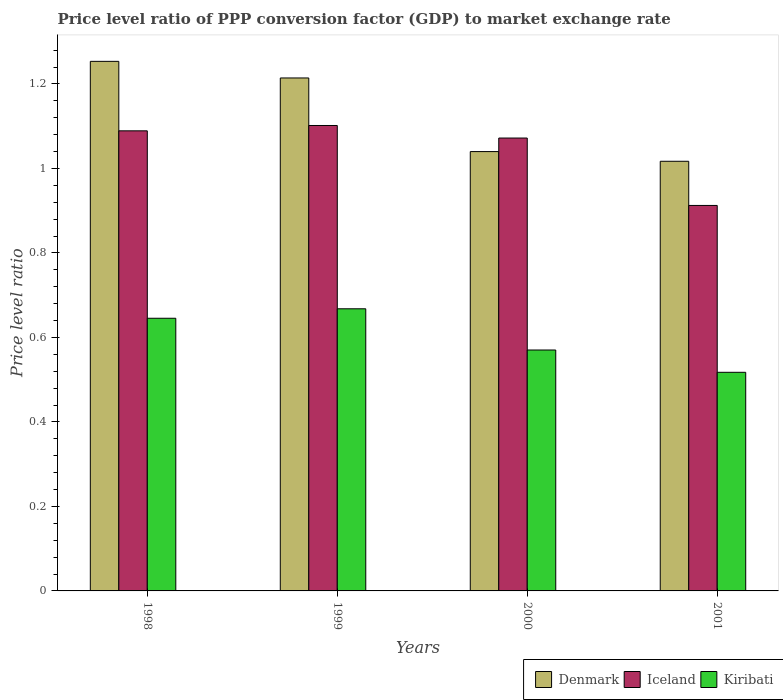How many different coloured bars are there?
Your answer should be very brief. 3. How many bars are there on the 3rd tick from the right?
Offer a very short reply. 3. What is the price level ratio in Denmark in 1999?
Offer a terse response. 1.21. Across all years, what is the maximum price level ratio in Kiribati?
Offer a terse response. 0.67. Across all years, what is the minimum price level ratio in Kiribati?
Give a very brief answer. 0.52. In which year was the price level ratio in Iceland maximum?
Make the answer very short. 1999. What is the total price level ratio in Denmark in the graph?
Ensure brevity in your answer.  4.52. What is the difference between the price level ratio in Iceland in 1999 and that in 2000?
Your response must be concise. 0.03. What is the difference between the price level ratio in Kiribati in 1998 and the price level ratio in Denmark in 2001?
Your response must be concise. -0.37. What is the average price level ratio in Denmark per year?
Keep it short and to the point. 1.13. In the year 1998, what is the difference between the price level ratio in Iceland and price level ratio in Denmark?
Your response must be concise. -0.16. What is the ratio of the price level ratio in Kiribati in 1998 to that in 2001?
Keep it short and to the point. 1.25. Is the price level ratio in Iceland in 1998 less than that in 1999?
Offer a very short reply. Yes. What is the difference between the highest and the second highest price level ratio in Iceland?
Offer a terse response. 0.01. What is the difference between the highest and the lowest price level ratio in Iceland?
Your answer should be compact. 0.19. In how many years, is the price level ratio in Iceland greater than the average price level ratio in Iceland taken over all years?
Provide a succinct answer. 3. What does the 1st bar from the right in 1998 represents?
Offer a terse response. Kiribati. Is it the case that in every year, the sum of the price level ratio in Iceland and price level ratio in Kiribati is greater than the price level ratio in Denmark?
Your answer should be very brief. Yes. Are all the bars in the graph horizontal?
Offer a terse response. No. How many years are there in the graph?
Offer a terse response. 4. Does the graph contain grids?
Offer a terse response. No. Where does the legend appear in the graph?
Provide a short and direct response. Bottom right. How many legend labels are there?
Offer a terse response. 3. How are the legend labels stacked?
Ensure brevity in your answer.  Horizontal. What is the title of the graph?
Make the answer very short. Price level ratio of PPP conversion factor (GDP) to market exchange rate. What is the label or title of the X-axis?
Offer a very short reply. Years. What is the label or title of the Y-axis?
Provide a short and direct response. Price level ratio. What is the Price level ratio in Denmark in 1998?
Your answer should be compact. 1.25. What is the Price level ratio of Iceland in 1998?
Keep it short and to the point. 1.09. What is the Price level ratio of Kiribati in 1998?
Provide a short and direct response. 0.65. What is the Price level ratio in Denmark in 1999?
Your answer should be compact. 1.21. What is the Price level ratio of Iceland in 1999?
Keep it short and to the point. 1.1. What is the Price level ratio in Kiribati in 1999?
Make the answer very short. 0.67. What is the Price level ratio in Denmark in 2000?
Offer a very short reply. 1.04. What is the Price level ratio in Iceland in 2000?
Make the answer very short. 1.07. What is the Price level ratio of Kiribati in 2000?
Your answer should be very brief. 0.57. What is the Price level ratio of Denmark in 2001?
Your answer should be compact. 1.02. What is the Price level ratio of Iceland in 2001?
Keep it short and to the point. 0.91. What is the Price level ratio in Kiribati in 2001?
Your answer should be very brief. 0.52. Across all years, what is the maximum Price level ratio of Denmark?
Give a very brief answer. 1.25. Across all years, what is the maximum Price level ratio of Iceland?
Your answer should be compact. 1.1. Across all years, what is the maximum Price level ratio in Kiribati?
Keep it short and to the point. 0.67. Across all years, what is the minimum Price level ratio in Denmark?
Give a very brief answer. 1.02. Across all years, what is the minimum Price level ratio in Iceland?
Give a very brief answer. 0.91. Across all years, what is the minimum Price level ratio in Kiribati?
Offer a very short reply. 0.52. What is the total Price level ratio in Denmark in the graph?
Your answer should be compact. 4.52. What is the total Price level ratio in Iceland in the graph?
Keep it short and to the point. 4.17. What is the total Price level ratio of Kiribati in the graph?
Offer a very short reply. 2.4. What is the difference between the Price level ratio of Denmark in 1998 and that in 1999?
Keep it short and to the point. 0.04. What is the difference between the Price level ratio in Iceland in 1998 and that in 1999?
Your response must be concise. -0.01. What is the difference between the Price level ratio of Kiribati in 1998 and that in 1999?
Your response must be concise. -0.02. What is the difference between the Price level ratio in Denmark in 1998 and that in 2000?
Give a very brief answer. 0.21. What is the difference between the Price level ratio of Iceland in 1998 and that in 2000?
Provide a short and direct response. 0.02. What is the difference between the Price level ratio of Kiribati in 1998 and that in 2000?
Your response must be concise. 0.08. What is the difference between the Price level ratio in Denmark in 1998 and that in 2001?
Make the answer very short. 0.24. What is the difference between the Price level ratio of Iceland in 1998 and that in 2001?
Ensure brevity in your answer.  0.18. What is the difference between the Price level ratio of Kiribati in 1998 and that in 2001?
Ensure brevity in your answer.  0.13. What is the difference between the Price level ratio of Denmark in 1999 and that in 2000?
Make the answer very short. 0.17. What is the difference between the Price level ratio of Iceland in 1999 and that in 2000?
Keep it short and to the point. 0.03. What is the difference between the Price level ratio of Kiribati in 1999 and that in 2000?
Provide a short and direct response. 0.1. What is the difference between the Price level ratio of Denmark in 1999 and that in 2001?
Provide a short and direct response. 0.2. What is the difference between the Price level ratio in Iceland in 1999 and that in 2001?
Provide a succinct answer. 0.19. What is the difference between the Price level ratio in Kiribati in 1999 and that in 2001?
Your answer should be very brief. 0.15. What is the difference between the Price level ratio in Denmark in 2000 and that in 2001?
Offer a very short reply. 0.02. What is the difference between the Price level ratio of Iceland in 2000 and that in 2001?
Ensure brevity in your answer.  0.16. What is the difference between the Price level ratio in Kiribati in 2000 and that in 2001?
Offer a terse response. 0.05. What is the difference between the Price level ratio in Denmark in 1998 and the Price level ratio in Iceland in 1999?
Your response must be concise. 0.15. What is the difference between the Price level ratio of Denmark in 1998 and the Price level ratio of Kiribati in 1999?
Make the answer very short. 0.59. What is the difference between the Price level ratio in Iceland in 1998 and the Price level ratio in Kiribati in 1999?
Provide a succinct answer. 0.42. What is the difference between the Price level ratio of Denmark in 1998 and the Price level ratio of Iceland in 2000?
Offer a terse response. 0.18. What is the difference between the Price level ratio in Denmark in 1998 and the Price level ratio in Kiribati in 2000?
Provide a succinct answer. 0.68. What is the difference between the Price level ratio of Iceland in 1998 and the Price level ratio of Kiribati in 2000?
Keep it short and to the point. 0.52. What is the difference between the Price level ratio in Denmark in 1998 and the Price level ratio in Iceland in 2001?
Provide a short and direct response. 0.34. What is the difference between the Price level ratio of Denmark in 1998 and the Price level ratio of Kiribati in 2001?
Your answer should be compact. 0.74. What is the difference between the Price level ratio of Iceland in 1998 and the Price level ratio of Kiribati in 2001?
Give a very brief answer. 0.57. What is the difference between the Price level ratio in Denmark in 1999 and the Price level ratio in Iceland in 2000?
Ensure brevity in your answer.  0.14. What is the difference between the Price level ratio in Denmark in 1999 and the Price level ratio in Kiribati in 2000?
Your answer should be compact. 0.64. What is the difference between the Price level ratio in Iceland in 1999 and the Price level ratio in Kiribati in 2000?
Provide a short and direct response. 0.53. What is the difference between the Price level ratio of Denmark in 1999 and the Price level ratio of Iceland in 2001?
Make the answer very short. 0.3. What is the difference between the Price level ratio in Denmark in 1999 and the Price level ratio in Kiribati in 2001?
Your answer should be compact. 0.7. What is the difference between the Price level ratio of Iceland in 1999 and the Price level ratio of Kiribati in 2001?
Ensure brevity in your answer.  0.58. What is the difference between the Price level ratio in Denmark in 2000 and the Price level ratio in Iceland in 2001?
Provide a succinct answer. 0.13. What is the difference between the Price level ratio in Denmark in 2000 and the Price level ratio in Kiribati in 2001?
Your response must be concise. 0.52. What is the difference between the Price level ratio of Iceland in 2000 and the Price level ratio of Kiribati in 2001?
Keep it short and to the point. 0.55. What is the average Price level ratio in Denmark per year?
Offer a very short reply. 1.13. What is the average Price level ratio in Iceland per year?
Provide a short and direct response. 1.04. What is the average Price level ratio of Kiribati per year?
Your answer should be very brief. 0.6. In the year 1998, what is the difference between the Price level ratio of Denmark and Price level ratio of Iceland?
Provide a succinct answer. 0.16. In the year 1998, what is the difference between the Price level ratio of Denmark and Price level ratio of Kiribati?
Provide a succinct answer. 0.61. In the year 1998, what is the difference between the Price level ratio in Iceland and Price level ratio in Kiribati?
Offer a terse response. 0.44. In the year 1999, what is the difference between the Price level ratio of Denmark and Price level ratio of Iceland?
Make the answer very short. 0.11. In the year 1999, what is the difference between the Price level ratio in Denmark and Price level ratio in Kiribati?
Ensure brevity in your answer.  0.55. In the year 1999, what is the difference between the Price level ratio of Iceland and Price level ratio of Kiribati?
Keep it short and to the point. 0.43. In the year 2000, what is the difference between the Price level ratio of Denmark and Price level ratio of Iceland?
Provide a succinct answer. -0.03. In the year 2000, what is the difference between the Price level ratio in Denmark and Price level ratio in Kiribati?
Give a very brief answer. 0.47. In the year 2000, what is the difference between the Price level ratio of Iceland and Price level ratio of Kiribati?
Keep it short and to the point. 0.5. In the year 2001, what is the difference between the Price level ratio in Denmark and Price level ratio in Iceland?
Make the answer very short. 0.1. In the year 2001, what is the difference between the Price level ratio of Denmark and Price level ratio of Kiribati?
Make the answer very short. 0.5. In the year 2001, what is the difference between the Price level ratio in Iceland and Price level ratio in Kiribati?
Give a very brief answer. 0.39. What is the ratio of the Price level ratio of Denmark in 1998 to that in 1999?
Provide a short and direct response. 1.03. What is the ratio of the Price level ratio in Iceland in 1998 to that in 1999?
Keep it short and to the point. 0.99. What is the ratio of the Price level ratio of Kiribati in 1998 to that in 1999?
Your answer should be compact. 0.97. What is the ratio of the Price level ratio of Denmark in 1998 to that in 2000?
Offer a terse response. 1.21. What is the ratio of the Price level ratio in Iceland in 1998 to that in 2000?
Your answer should be very brief. 1.02. What is the ratio of the Price level ratio in Kiribati in 1998 to that in 2000?
Keep it short and to the point. 1.13. What is the ratio of the Price level ratio in Denmark in 1998 to that in 2001?
Keep it short and to the point. 1.23. What is the ratio of the Price level ratio of Iceland in 1998 to that in 2001?
Ensure brevity in your answer.  1.19. What is the ratio of the Price level ratio in Kiribati in 1998 to that in 2001?
Offer a very short reply. 1.25. What is the ratio of the Price level ratio in Denmark in 1999 to that in 2000?
Provide a succinct answer. 1.17. What is the ratio of the Price level ratio of Iceland in 1999 to that in 2000?
Ensure brevity in your answer.  1.03. What is the ratio of the Price level ratio in Kiribati in 1999 to that in 2000?
Offer a terse response. 1.17. What is the ratio of the Price level ratio of Denmark in 1999 to that in 2001?
Provide a short and direct response. 1.19. What is the ratio of the Price level ratio of Iceland in 1999 to that in 2001?
Your answer should be compact. 1.21. What is the ratio of the Price level ratio of Kiribati in 1999 to that in 2001?
Ensure brevity in your answer.  1.29. What is the ratio of the Price level ratio of Denmark in 2000 to that in 2001?
Your answer should be compact. 1.02. What is the ratio of the Price level ratio in Iceland in 2000 to that in 2001?
Your answer should be compact. 1.17. What is the ratio of the Price level ratio of Kiribati in 2000 to that in 2001?
Provide a short and direct response. 1.1. What is the difference between the highest and the second highest Price level ratio of Denmark?
Provide a succinct answer. 0.04. What is the difference between the highest and the second highest Price level ratio of Iceland?
Provide a short and direct response. 0.01. What is the difference between the highest and the second highest Price level ratio of Kiribati?
Keep it short and to the point. 0.02. What is the difference between the highest and the lowest Price level ratio of Denmark?
Your answer should be compact. 0.24. What is the difference between the highest and the lowest Price level ratio in Iceland?
Provide a succinct answer. 0.19. What is the difference between the highest and the lowest Price level ratio of Kiribati?
Give a very brief answer. 0.15. 